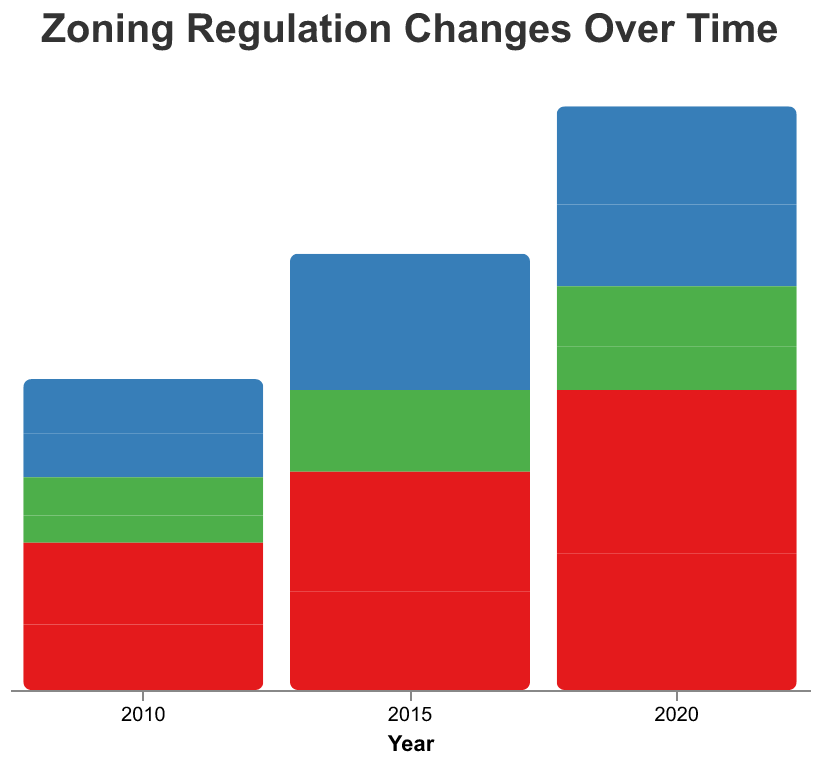What is the title of the figure? The title of the figure is displayed at the top of the chart. It reads "Zoning Regulation Changes Over Time."
Answer: Zoning Regulation Changes Over Time What are the categories for Land Use Type represented in the figure? The Land Use Types are indicated by color codes and labels. The categories are Residential (red), Commercial (blue), and Industrial (green).
Answer: Residential, Commercial, Industrial How many regulation changes were made for Residential land use in Los Angeles in 2020? Look at the grid for Los Angeles and Residential in the year 2020. The bar's height indicates the number of regulation changes, which is labeled as 25.
Answer: 25 What's the total number of regulation changes for Commercial land use in New York City across all years displayed? Sum the regulation changes for the years 2010 (10), 2015 (14), and 2020 (18) in New York City for Commercial land use: 10 + 14 + 18 = 42.
Answer: 42 Which jurisdiction had more regulation changes for Industrial land use in 2015? Compare the bars for Los Angeles (6) and New York City (9) in 2015 within the Industrial category. New York City had more changes.
Answer: New York City What is the increase in regulation changes for Residential land use in Los Angeles from 2010 to 2020? Subtract the number of Residential regulation changes in 2010 (12) from the number in 2020 (25): 25 - 12 = 13.
Answer: 13 Which Land Use Type saw the highest number of regulation changes in New York City in 2020? Check the bars for each Land Use Type in New York City for the year 2020. Residential (30) is the highest compared to Commercial (18) and Industrial (11).
Answer: Residential How do the numbers of regulation changes for Commercial land use in both cities compare in 2015? Look at the bars for Commercial in 2015 for Los Angeles (11) and New York City (14). New York City had more regulation changes.
Answer: New York City Which city had a consistent increase in regulation changes for Residential land use over the years? Compare the bars for Residential for each year. Los Angeles shows a consistent increase from 12 (2010) to 18 (2015) to 25 (2020).
Answer: Los Angeles In which Land Use Type and year did Los Angeles and New York City have the same number of regulation changes? Compare the bars across all categories and years. In 2010, Los Angeles and New York City both had the same number of Industrial regulation changes, which is 7.
Answer: Industrial, 2010 